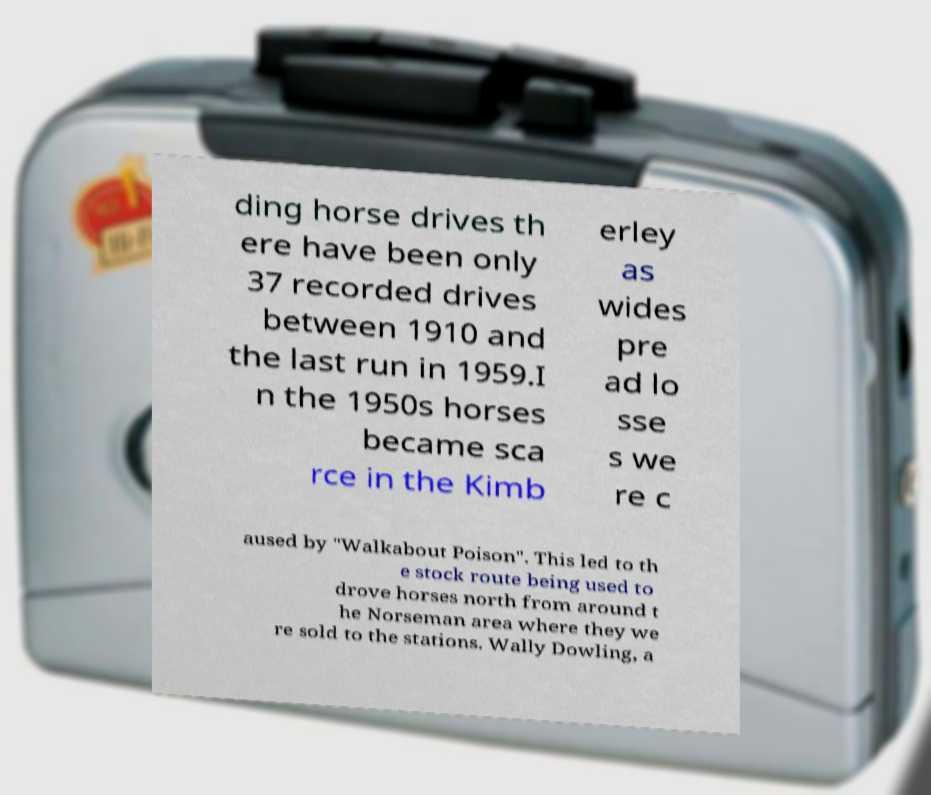There's text embedded in this image that I need extracted. Can you transcribe it verbatim? ding horse drives th ere have been only 37 recorded drives between 1910 and the last run in 1959.I n the 1950s horses became sca rce in the Kimb erley as wides pre ad lo sse s we re c aused by "Walkabout Poison". This led to th e stock route being used to drove horses north from around t he Norseman area where they we re sold to the stations. Wally Dowling, a 